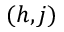<formula> <loc_0><loc_0><loc_500><loc_500>( h , j )</formula> 